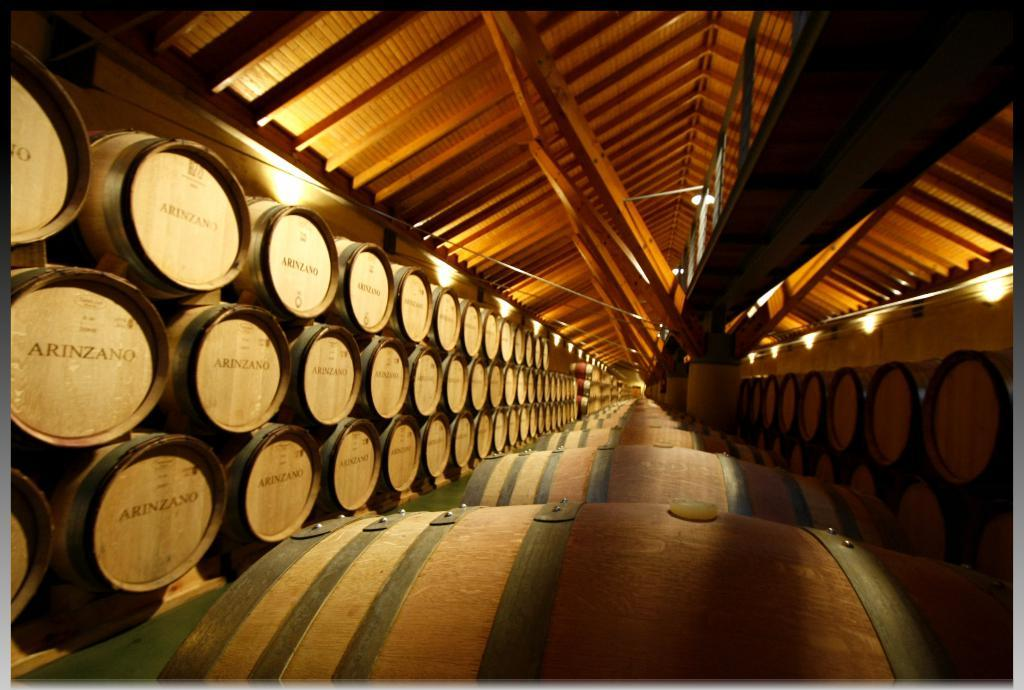Provide a one-sentence caption for the provided image. Arinzano wine barrels are stacked on top of each other along a long and narrow room. 